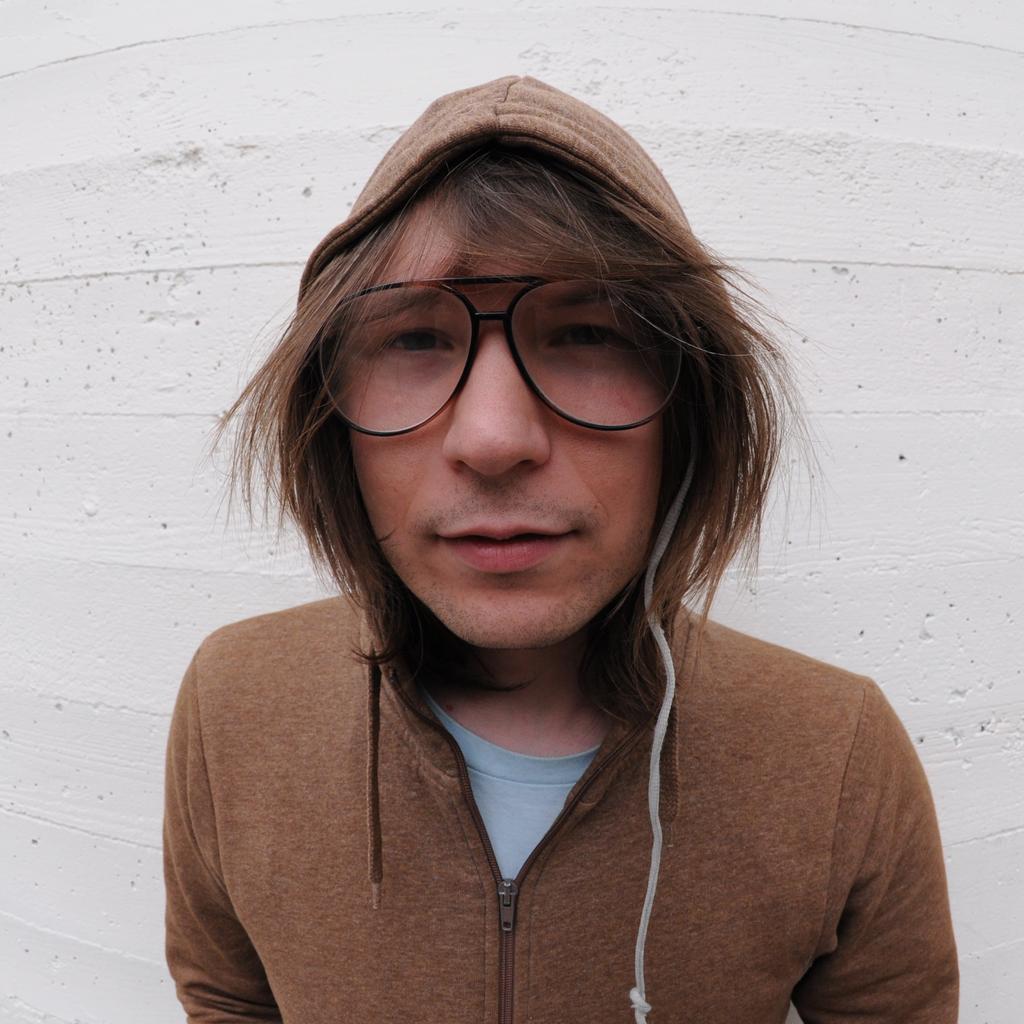Could you give a brief overview of what you see in this image? In this image we can see one man with spectacles standing and background there is one big white wall. 